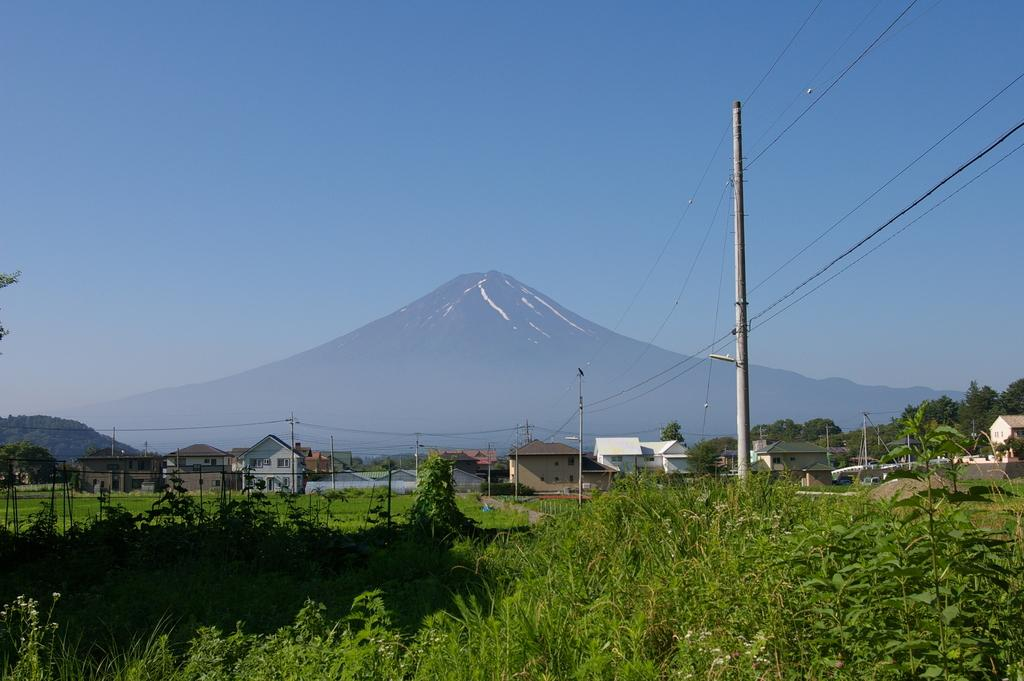What type of living organisms can be seen in the image? Plants can be seen in the image. What are the vertical structures in the image? There are poles in the image. What are the thin, elongated objects in the image? There are wires in the image. What can be seen in the distance in the image? There are houses, trees, and mountains in the background of the image. What is visible at the top of the image? The sky is clear at the top of the image. How many men are standing under the shade of the trees in the image? There are no men present in the image; it only features plants, poles, wires, houses, trees, mountains, and a clear sky. 